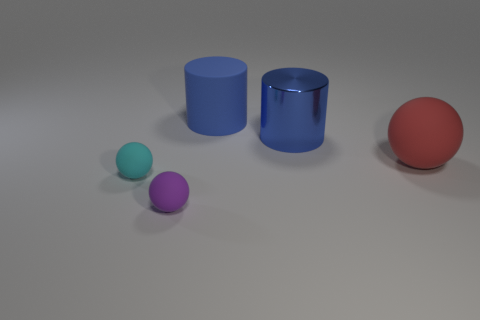There is a blue thing on the right side of the blue matte cylinder; does it have the same shape as the large red matte thing?
Your response must be concise. No. There is a tiny object on the left side of the purple sphere left of the big blue matte cylinder; what is its color?
Your answer should be very brief. Cyan. Are there fewer cyan matte things than small yellow shiny things?
Offer a very short reply. No. Is there another cyan ball that has the same material as the large ball?
Provide a succinct answer. Yes. There is a purple thing; does it have the same shape as the blue object that is in front of the big matte cylinder?
Ensure brevity in your answer.  No. Are there any large red matte balls on the right side of the small purple matte object?
Your answer should be very brief. Yes. What number of other blue objects are the same shape as the blue matte object?
Offer a terse response. 1. Is the big red thing made of the same material as the blue cylinder that is in front of the big blue rubber cylinder?
Offer a very short reply. No. What number of big purple matte spheres are there?
Provide a short and direct response. 0. How big is the sphere in front of the cyan rubber sphere?
Your response must be concise. Small. 